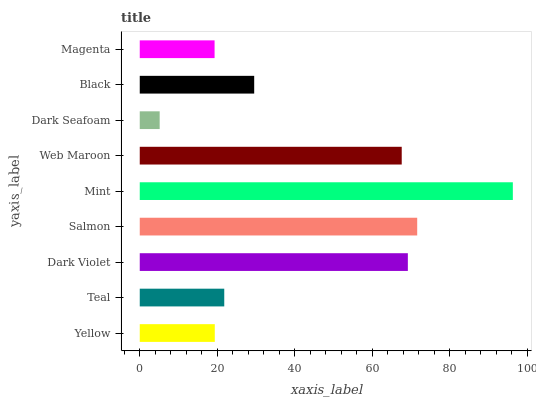Is Dark Seafoam the minimum?
Answer yes or no. Yes. Is Mint the maximum?
Answer yes or no. Yes. Is Teal the minimum?
Answer yes or no. No. Is Teal the maximum?
Answer yes or no. No. Is Teal greater than Yellow?
Answer yes or no. Yes. Is Yellow less than Teal?
Answer yes or no. Yes. Is Yellow greater than Teal?
Answer yes or no. No. Is Teal less than Yellow?
Answer yes or no. No. Is Black the high median?
Answer yes or no. Yes. Is Black the low median?
Answer yes or no. Yes. Is Teal the high median?
Answer yes or no. No. Is Salmon the low median?
Answer yes or no. No. 